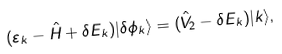<formula> <loc_0><loc_0><loc_500><loc_500>( \varepsilon _ { k } - \hat { H } + \delta E _ { k } ) | \delta \phi _ { k } \rangle = ( \hat { V } _ { 2 } - \delta E _ { k } ) | k \rangle ,</formula> 